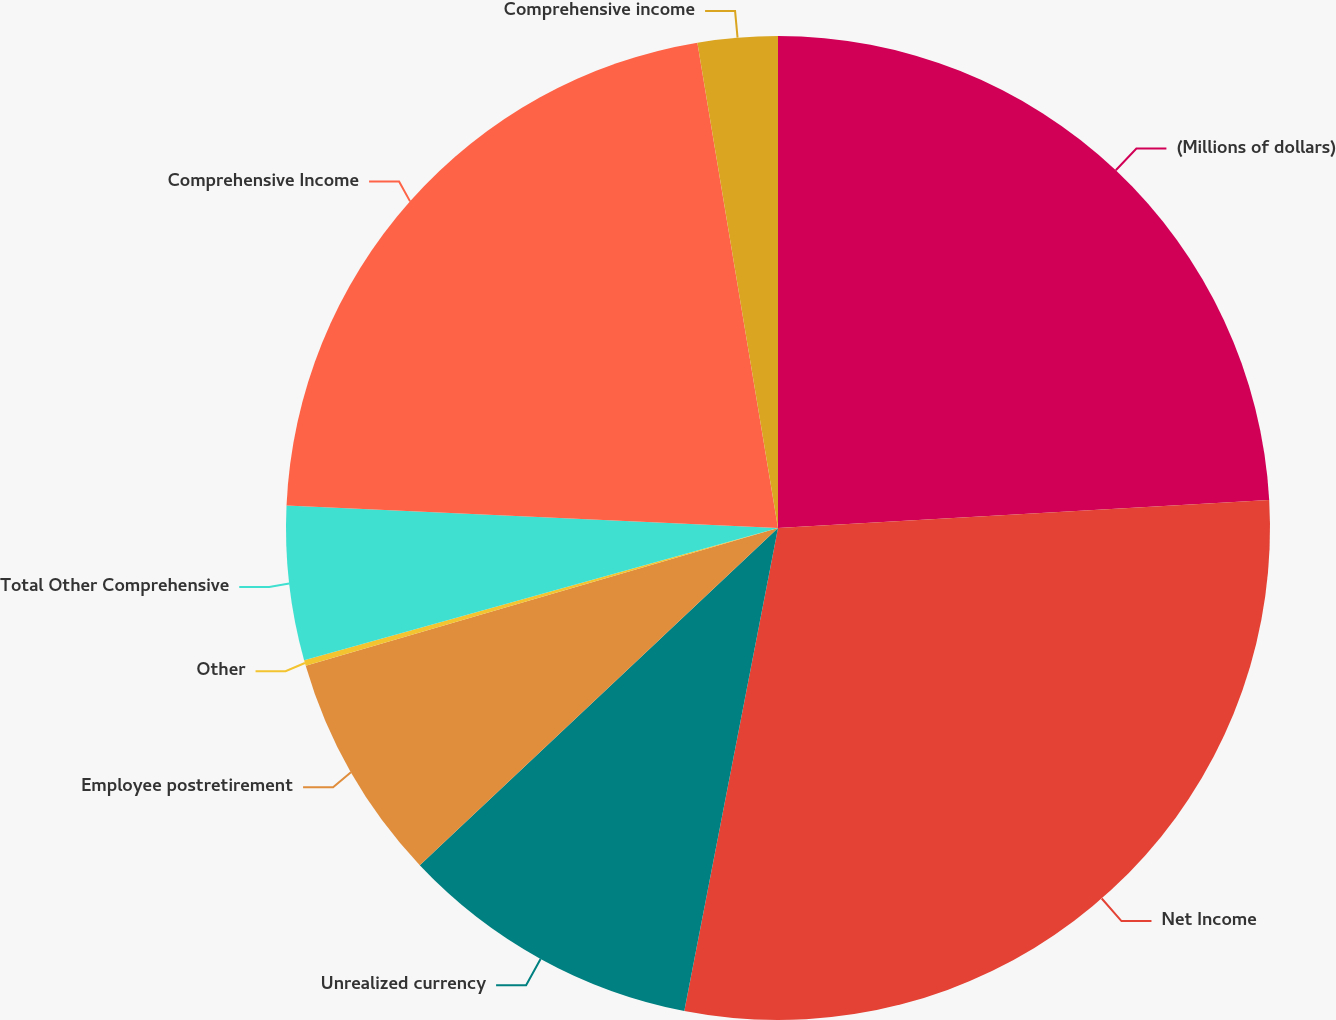Convert chart. <chart><loc_0><loc_0><loc_500><loc_500><pie_chart><fcel>(Millions of dollars)<fcel>Net Income<fcel>Unrealized currency<fcel>Employee postretirement<fcel>Other<fcel>Total Other Comprehensive<fcel>Comprehensive Income<fcel>Comprehensive income<nl><fcel>24.09%<fcel>28.96%<fcel>9.93%<fcel>7.5%<fcel>0.19%<fcel>5.06%<fcel>21.65%<fcel>2.62%<nl></chart> 